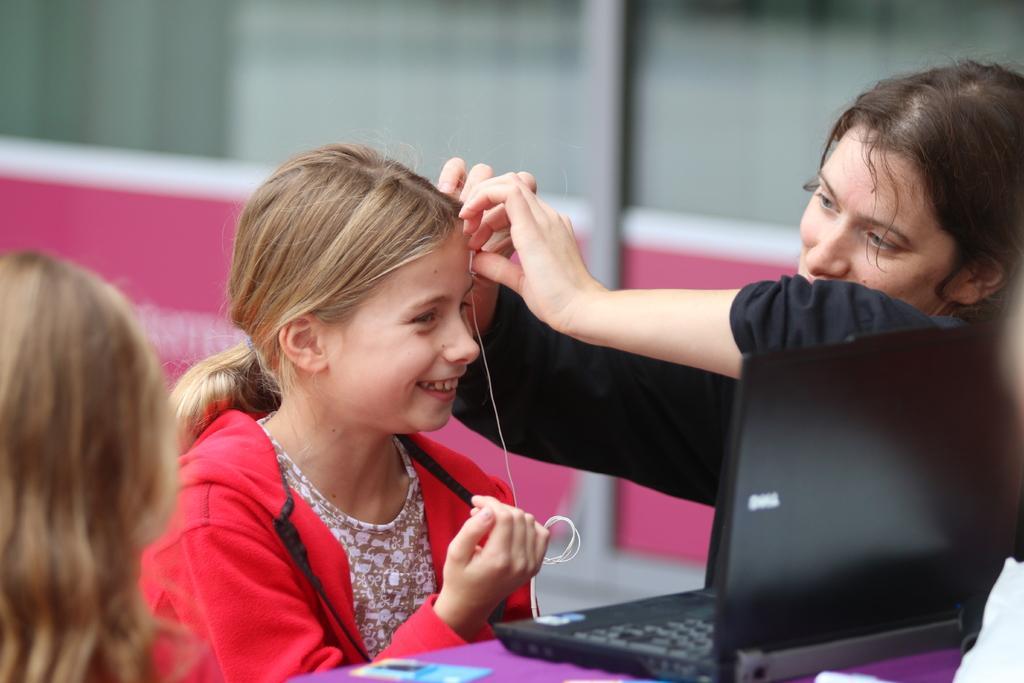Can you describe this image briefly? In this image on the right side there is a woman who is tying the thread to the girl, in front of the girl there is a laptop on the table, on the left I can see a person head, in the background there may be the wall. 